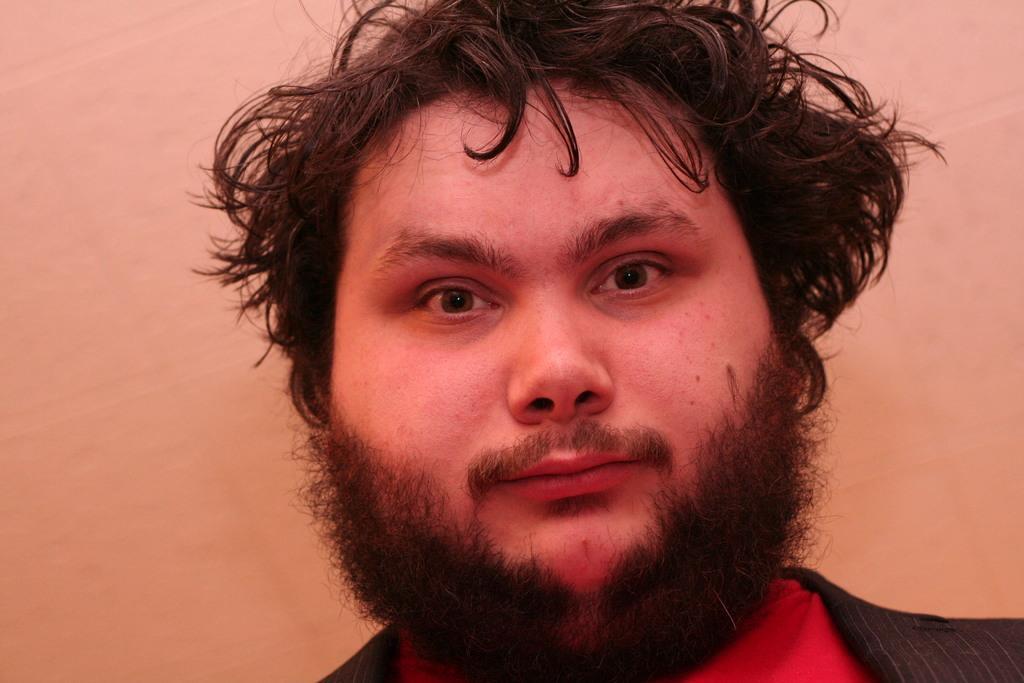Can you describe this image briefly? In this image in front there is a person. Behind him there is a wall. 